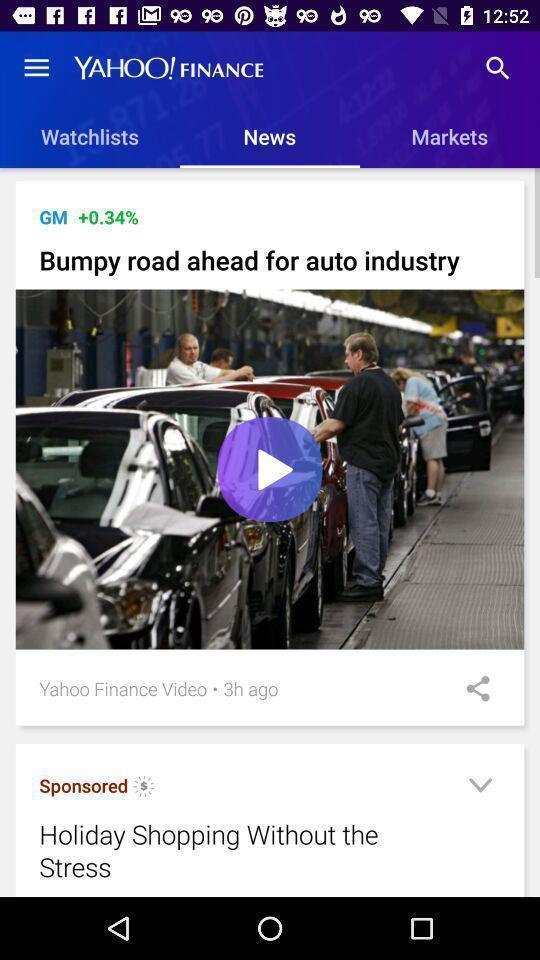Tell me what you see in this picture. Page of a financial app with various options. 